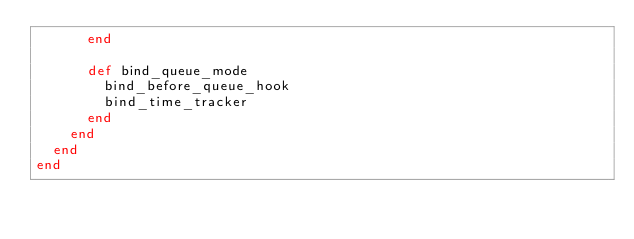Convert code to text. <code><loc_0><loc_0><loc_500><loc_500><_Ruby_>      end

      def bind_queue_mode
        bind_before_queue_hook
        bind_time_tracker
      end
    end
  end
end
</code> 